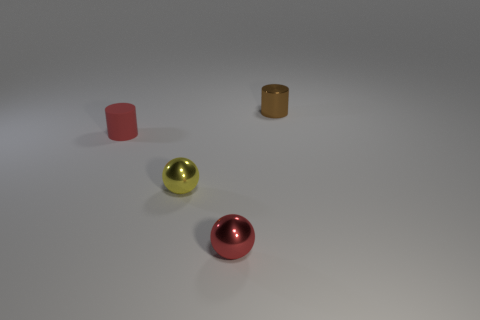What materials do the objects in the image appear to be made of? The objects display characteristics of different materials: the cylinders and the sphere seem to have a metallic sheen, suggesting they could be made of metal, while the surfaces have matte finishes which might indicate a plastic or painted metal composition. 